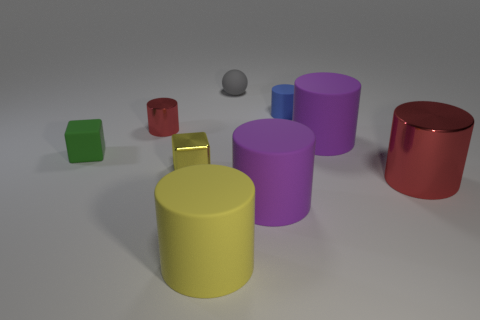Subtract all small red cylinders. How many cylinders are left? 5 Subtract all brown balls. How many red cylinders are left? 2 Subtract all blue cylinders. How many cylinders are left? 5 Subtract all blocks. How many objects are left? 7 Subtract all gray cylinders. Subtract all brown cubes. How many cylinders are left? 6 Add 1 big blue blocks. How many objects exist? 10 Subtract all purple matte cylinders. Subtract all large yellow objects. How many objects are left? 6 Add 7 blue matte cylinders. How many blue matte cylinders are left? 8 Add 5 red metal cylinders. How many red metal cylinders exist? 7 Subtract 2 red cylinders. How many objects are left? 7 